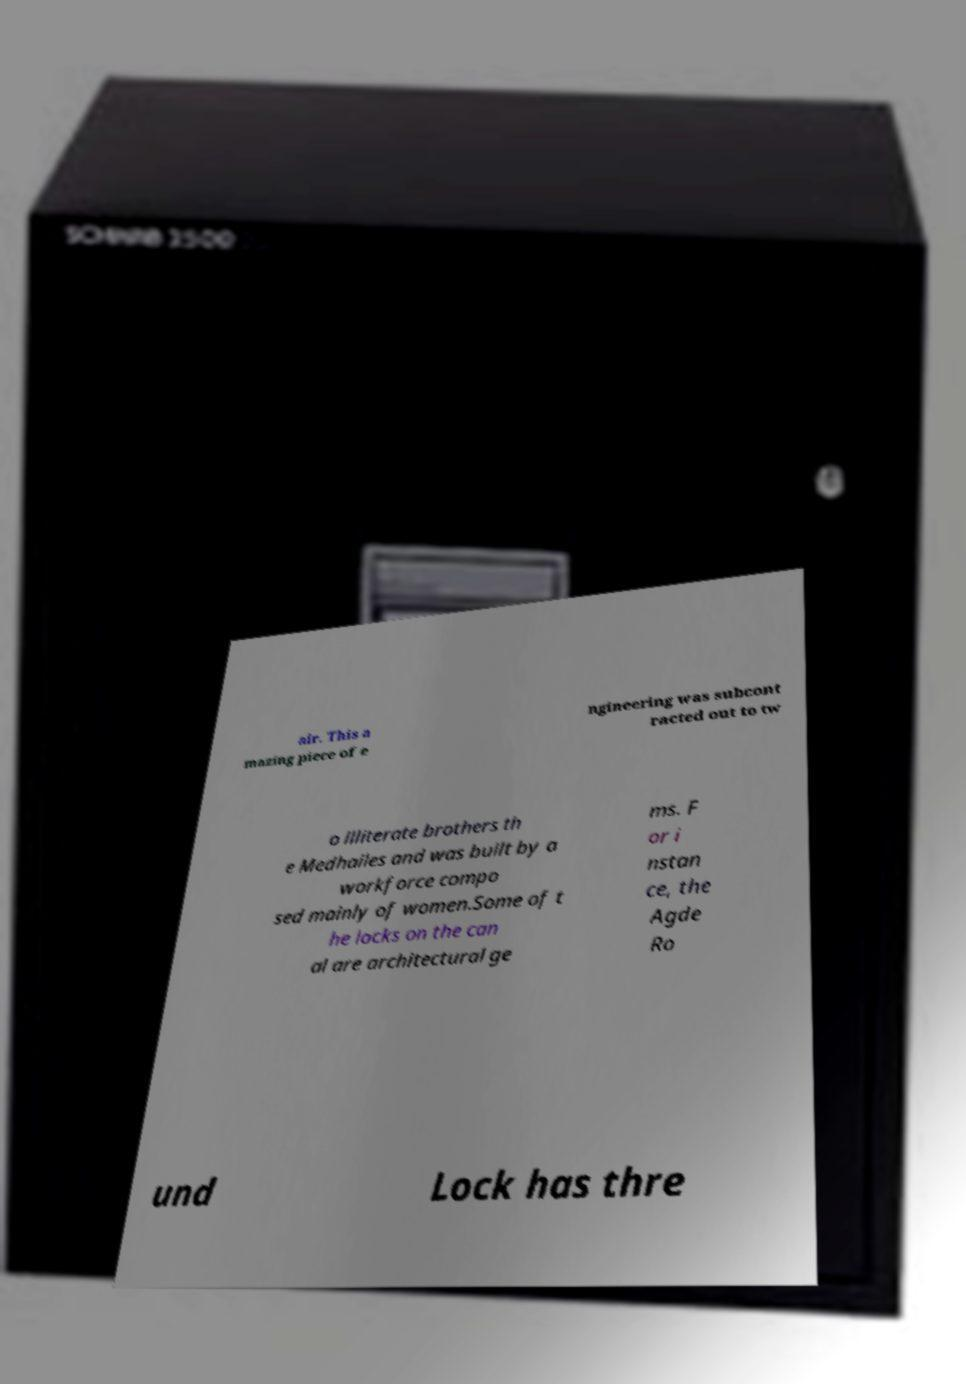Can you accurately transcribe the text from the provided image for me? air. This a mazing piece of e ngineering was subcont racted out to tw o illiterate brothers th e Medhailes and was built by a workforce compo sed mainly of women.Some of t he locks on the can al are architectural ge ms. F or i nstan ce, the Agde Ro und Lock has thre 